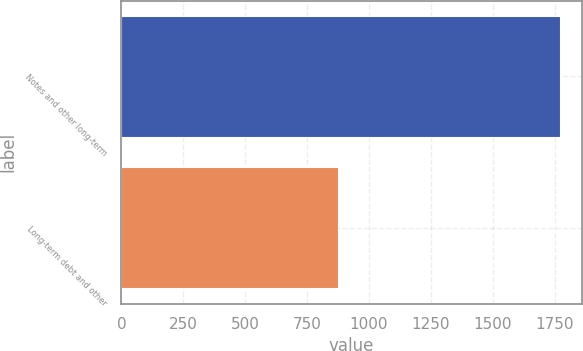<chart> <loc_0><loc_0><loc_500><loc_500><bar_chart><fcel>Notes and other long-term<fcel>Long-term debt and other<nl><fcel>1770<fcel>875<nl></chart> 